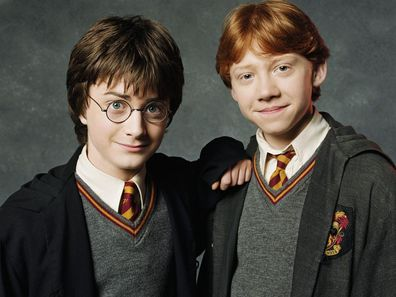What might Harry and Ron be discussing in this image? In this image, Harry Potter and Ron Weasley could be discussing their latest adventures at Hogwarts. Perhaps they're excitedly talking about their recent encounter with a magical creature in Hagrid’s class or planning their next strategy for a Quidditch match. Given Harry's bemused expression and Ron's slight smile, it’s likely a light-hearted and friendly conversation, conveying the warmth and camaraderie between the two best friends. 